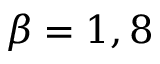Convert formula to latex. <formula><loc_0><loc_0><loc_500><loc_500>\beta = 1 , 8</formula> 